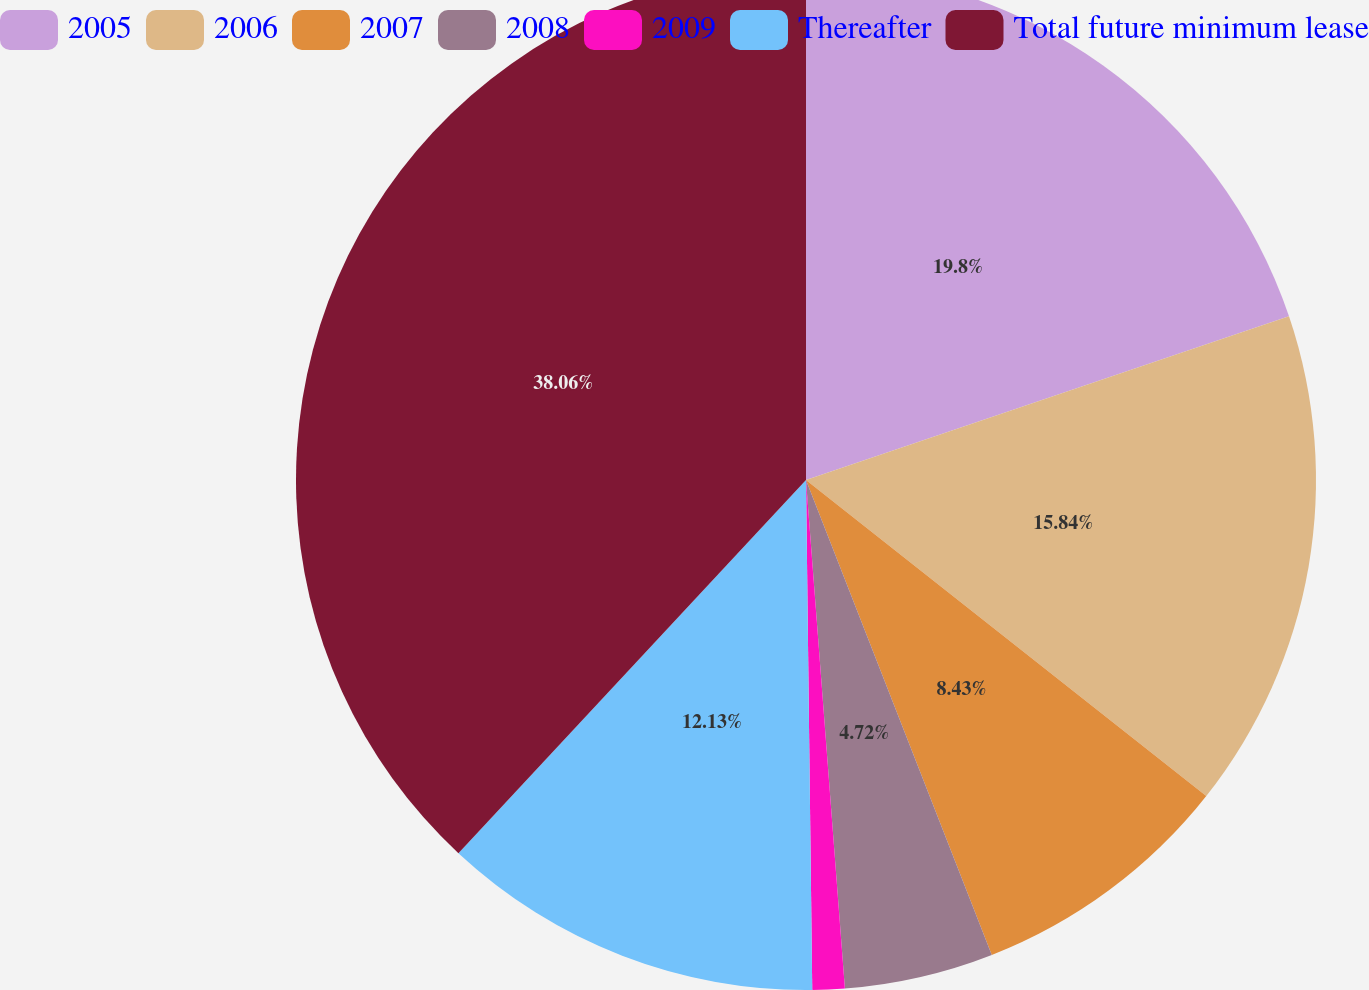Convert chart to OTSL. <chart><loc_0><loc_0><loc_500><loc_500><pie_chart><fcel>2005<fcel>2006<fcel>2007<fcel>2008<fcel>2009<fcel>Thereafter<fcel>Total future minimum lease<nl><fcel>19.8%<fcel>15.84%<fcel>8.43%<fcel>4.72%<fcel>1.02%<fcel>12.13%<fcel>38.07%<nl></chart> 